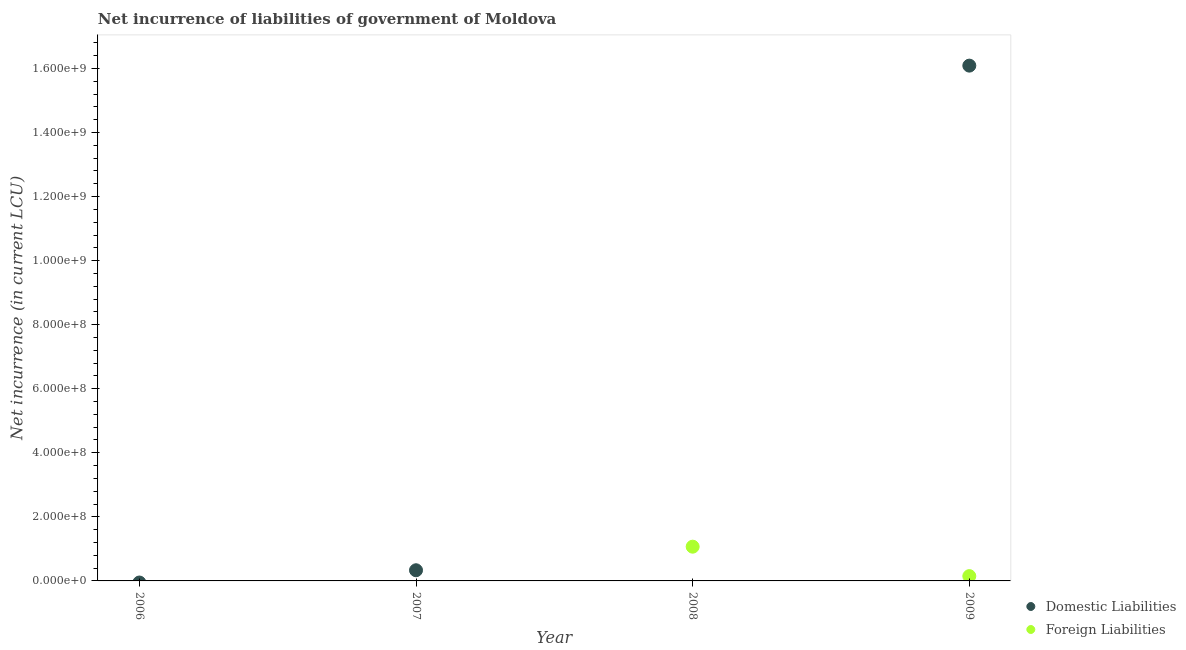What is the net incurrence of domestic liabilities in 2007?
Your response must be concise. 3.33e+07. Across all years, what is the maximum net incurrence of domestic liabilities?
Give a very brief answer. 1.61e+09. Across all years, what is the minimum net incurrence of foreign liabilities?
Ensure brevity in your answer.  0. In which year was the net incurrence of domestic liabilities maximum?
Ensure brevity in your answer.  2009. What is the total net incurrence of foreign liabilities in the graph?
Your response must be concise. 1.22e+08. What is the difference between the net incurrence of foreign liabilities in 2008 and the net incurrence of domestic liabilities in 2009?
Offer a very short reply. -1.50e+09. What is the average net incurrence of foreign liabilities per year?
Offer a very short reply. 3.05e+07. In the year 2009, what is the difference between the net incurrence of domestic liabilities and net incurrence of foreign liabilities?
Your answer should be compact. 1.59e+09. In how many years, is the net incurrence of foreign liabilities greater than 1560000000 LCU?
Provide a short and direct response. 0. What is the difference between the highest and the lowest net incurrence of domestic liabilities?
Your answer should be very brief. 1.61e+09. Is the net incurrence of foreign liabilities strictly less than the net incurrence of domestic liabilities over the years?
Your answer should be very brief. No. How many dotlines are there?
Your answer should be very brief. 2. Does the graph contain any zero values?
Offer a terse response. Yes. Does the graph contain grids?
Your response must be concise. No. Where does the legend appear in the graph?
Keep it short and to the point. Bottom right. How are the legend labels stacked?
Your answer should be compact. Vertical. What is the title of the graph?
Your response must be concise. Net incurrence of liabilities of government of Moldova. Does "Primary school" appear as one of the legend labels in the graph?
Offer a terse response. No. What is the label or title of the X-axis?
Your response must be concise. Year. What is the label or title of the Y-axis?
Make the answer very short. Net incurrence (in current LCU). What is the Net incurrence (in current LCU) in Domestic Liabilities in 2006?
Provide a succinct answer. 0. What is the Net incurrence (in current LCU) of Foreign Liabilities in 2006?
Ensure brevity in your answer.  0. What is the Net incurrence (in current LCU) of Domestic Liabilities in 2007?
Give a very brief answer. 3.33e+07. What is the Net incurrence (in current LCU) in Foreign Liabilities in 2007?
Your response must be concise. 0. What is the Net incurrence (in current LCU) of Foreign Liabilities in 2008?
Your answer should be compact. 1.07e+08. What is the Net incurrence (in current LCU) of Domestic Liabilities in 2009?
Keep it short and to the point. 1.61e+09. What is the Net incurrence (in current LCU) in Foreign Liabilities in 2009?
Offer a very short reply. 1.50e+07. Across all years, what is the maximum Net incurrence (in current LCU) in Domestic Liabilities?
Ensure brevity in your answer.  1.61e+09. Across all years, what is the maximum Net incurrence (in current LCU) in Foreign Liabilities?
Give a very brief answer. 1.07e+08. Across all years, what is the minimum Net incurrence (in current LCU) of Domestic Liabilities?
Your answer should be compact. 0. What is the total Net incurrence (in current LCU) of Domestic Liabilities in the graph?
Ensure brevity in your answer.  1.64e+09. What is the total Net incurrence (in current LCU) of Foreign Liabilities in the graph?
Provide a short and direct response. 1.22e+08. What is the difference between the Net incurrence (in current LCU) in Domestic Liabilities in 2007 and that in 2009?
Your answer should be very brief. -1.58e+09. What is the difference between the Net incurrence (in current LCU) in Foreign Liabilities in 2008 and that in 2009?
Keep it short and to the point. 9.19e+07. What is the difference between the Net incurrence (in current LCU) of Domestic Liabilities in 2007 and the Net incurrence (in current LCU) of Foreign Liabilities in 2008?
Your answer should be very brief. -7.36e+07. What is the difference between the Net incurrence (in current LCU) of Domestic Liabilities in 2007 and the Net incurrence (in current LCU) of Foreign Liabilities in 2009?
Give a very brief answer. 1.83e+07. What is the average Net incurrence (in current LCU) in Domestic Liabilities per year?
Your answer should be compact. 4.11e+08. What is the average Net incurrence (in current LCU) in Foreign Liabilities per year?
Provide a succinct answer. 3.05e+07. In the year 2009, what is the difference between the Net incurrence (in current LCU) of Domestic Liabilities and Net incurrence (in current LCU) of Foreign Liabilities?
Make the answer very short. 1.59e+09. What is the ratio of the Net incurrence (in current LCU) in Domestic Liabilities in 2007 to that in 2009?
Provide a succinct answer. 0.02. What is the ratio of the Net incurrence (in current LCU) in Foreign Liabilities in 2008 to that in 2009?
Offer a very short reply. 7.13. What is the difference between the highest and the lowest Net incurrence (in current LCU) of Domestic Liabilities?
Ensure brevity in your answer.  1.61e+09. What is the difference between the highest and the lowest Net incurrence (in current LCU) in Foreign Liabilities?
Ensure brevity in your answer.  1.07e+08. 